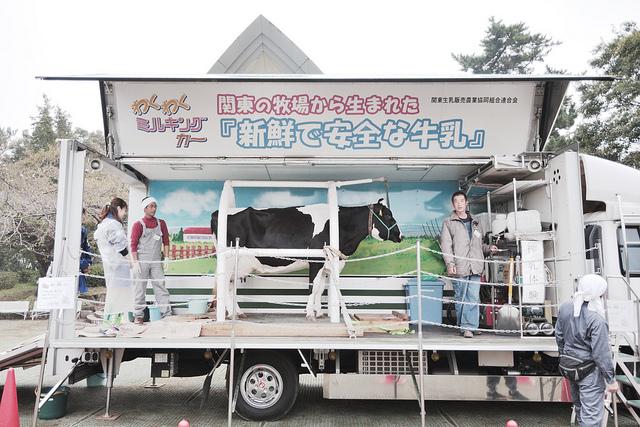What color are the items on the truck?
Concise answer only. White. Is the writing in French?
Give a very brief answer. No. Is this a traveling circus?
Concise answer only. No. What animal is on the flatbed?
Quick response, please. Cow. 